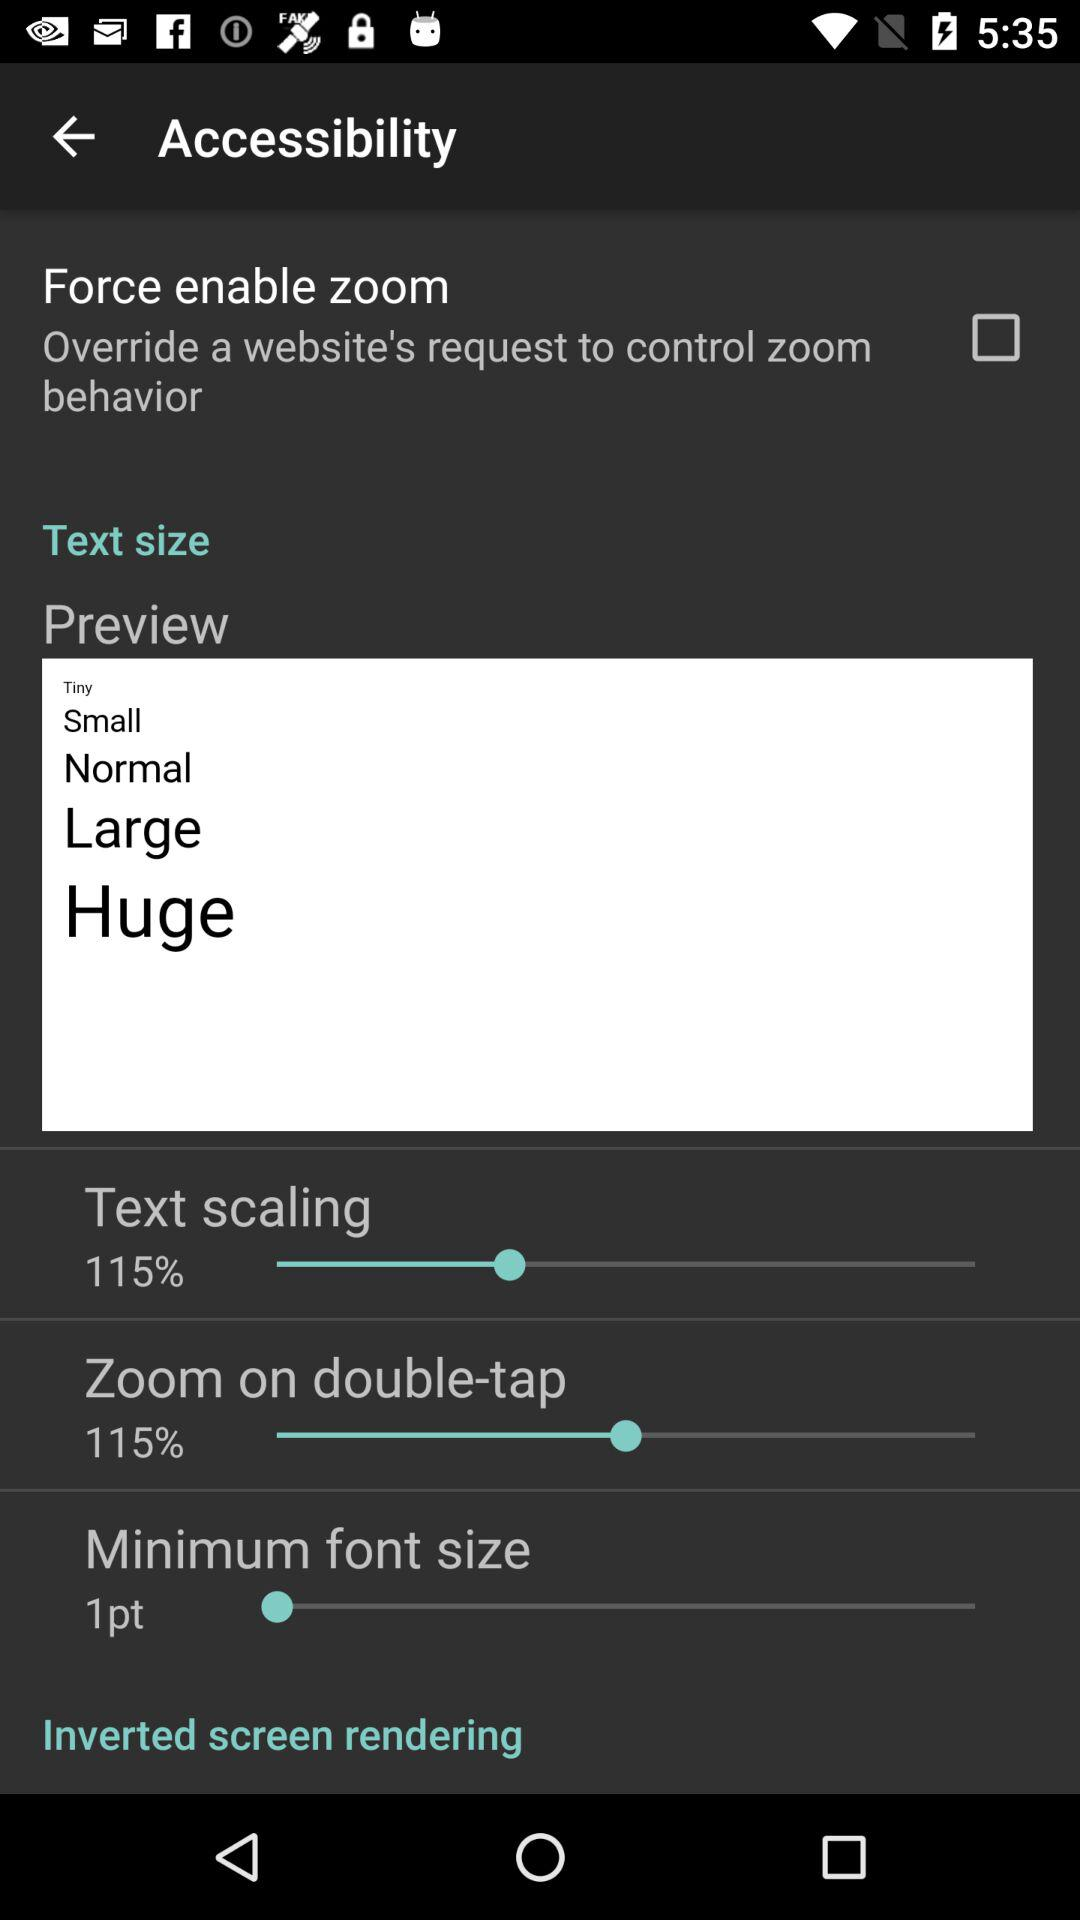What is the status of "Force enable zoom"? The status of "Force enable zoom" is "off". 